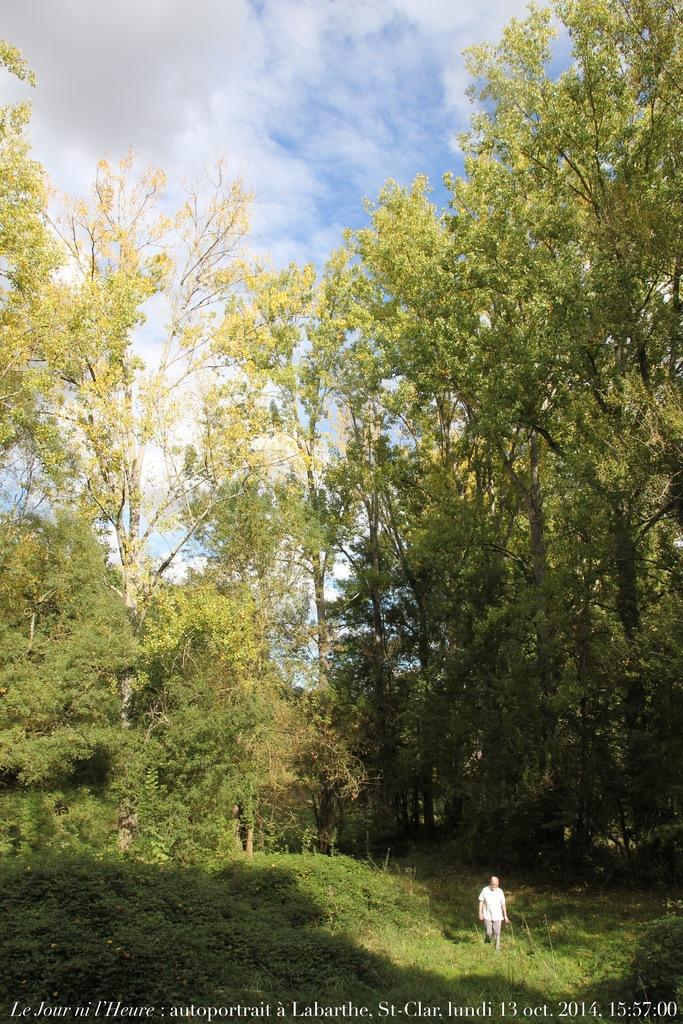How would you summarize this image in a sentence or two? In this picture I can see a person standing, there are plants, trees, and in the background there is the sky and there is a watermark on the image. 